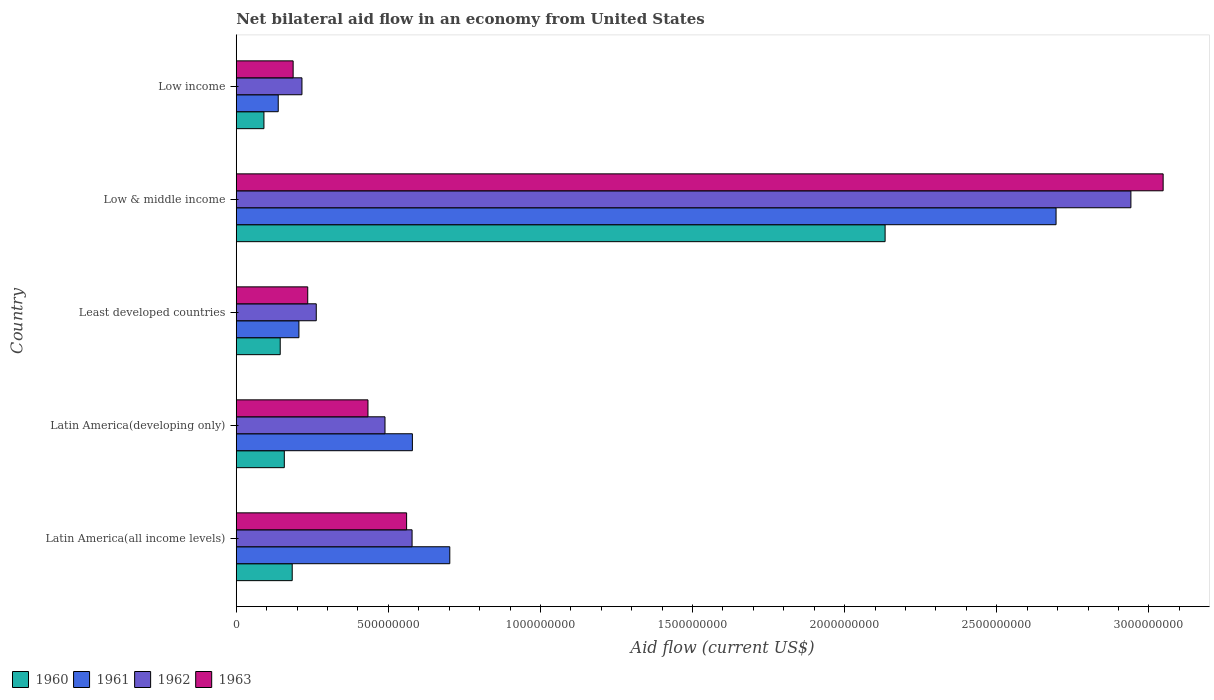Are the number of bars on each tick of the Y-axis equal?
Your answer should be very brief. Yes. How many bars are there on the 3rd tick from the top?
Your answer should be compact. 4. How many bars are there on the 5th tick from the bottom?
Keep it short and to the point. 4. What is the label of the 2nd group of bars from the top?
Your answer should be compact. Low & middle income. What is the net bilateral aid flow in 1960 in Low income?
Ensure brevity in your answer.  9.10e+07. Across all countries, what is the maximum net bilateral aid flow in 1963?
Give a very brief answer. 3.05e+09. Across all countries, what is the minimum net bilateral aid flow in 1962?
Your answer should be very brief. 2.16e+08. In which country was the net bilateral aid flow in 1963 minimum?
Give a very brief answer. Low income. What is the total net bilateral aid flow in 1961 in the graph?
Your response must be concise. 4.32e+09. What is the difference between the net bilateral aid flow in 1960 in Latin America(developing only) and that in Low & middle income?
Provide a short and direct response. -1.98e+09. What is the difference between the net bilateral aid flow in 1963 in Latin America(all income levels) and the net bilateral aid flow in 1961 in Least developed countries?
Offer a terse response. 3.54e+08. What is the average net bilateral aid flow in 1963 per country?
Give a very brief answer. 8.92e+08. What is the difference between the net bilateral aid flow in 1962 and net bilateral aid flow in 1961 in Latin America(all income levels)?
Ensure brevity in your answer.  -1.24e+08. What is the ratio of the net bilateral aid flow in 1961 in Least developed countries to that in Low & middle income?
Your answer should be very brief. 0.08. Is the difference between the net bilateral aid flow in 1962 in Latin America(all income levels) and Latin America(developing only) greater than the difference between the net bilateral aid flow in 1961 in Latin America(all income levels) and Latin America(developing only)?
Your answer should be very brief. No. What is the difference between the highest and the second highest net bilateral aid flow in 1963?
Offer a terse response. 2.49e+09. What is the difference between the highest and the lowest net bilateral aid flow in 1960?
Your answer should be compact. 2.04e+09. In how many countries, is the net bilateral aid flow in 1962 greater than the average net bilateral aid flow in 1962 taken over all countries?
Your answer should be compact. 1. What does the 4th bar from the top in Low income represents?
Provide a short and direct response. 1960. Is it the case that in every country, the sum of the net bilateral aid flow in 1962 and net bilateral aid flow in 1963 is greater than the net bilateral aid flow in 1960?
Provide a succinct answer. Yes. How many bars are there?
Your answer should be compact. 20. Are all the bars in the graph horizontal?
Give a very brief answer. Yes. How many countries are there in the graph?
Keep it short and to the point. 5. What is the difference between two consecutive major ticks on the X-axis?
Provide a succinct answer. 5.00e+08. Does the graph contain any zero values?
Keep it short and to the point. No. Does the graph contain grids?
Your response must be concise. No. What is the title of the graph?
Keep it short and to the point. Net bilateral aid flow in an economy from United States. What is the label or title of the X-axis?
Your answer should be compact. Aid flow (current US$). What is the label or title of the Y-axis?
Give a very brief answer. Country. What is the Aid flow (current US$) of 1960 in Latin America(all income levels)?
Provide a succinct answer. 1.84e+08. What is the Aid flow (current US$) of 1961 in Latin America(all income levels)?
Your answer should be very brief. 7.02e+08. What is the Aid flow (current US$) of 1962 in Latin America(all income levels)?
Provide a succinct answer. 5.78e+08. What is the Aid flow (current US$) of 1963 in Latin America(all income levels)?
Offer a very short reply. 5.60e+08. What is the Aid flow (current US$) in 1960 in Latin America(developing only)?
Make the answer very short. 1.58e+08. What is the Aid flow (current US$) of 1961 in Latin America(developing only)?
Provide a succinct answer. 5.79e+08. What is the Aid flow (current US$) in 1962 in Latin America(developing only)?
Keep it short and to the point. 4.89e+08. What is the Aid flow (current US$) of 1963 in Latin America(developing only)?
Provide a short and direct response. 4.33e+08. What is the Aid flow (current US$) of 1960 in Least developed countries?
Your answer should be compact. 1.45e+08. What is the Aid flow (current US$) in 1961 in Least developed countries?
Offer a very short reply. 2.06e+08. What is the Aid flow (current US$) in 1962 in Least developed countries?
Ensure brevity in your answer.  2.63e+08. What is the Aid flow (current US$) of 1963 in Least developed countries?
Ensure brevity in your answer.  2.35e+08. What is the Aid flow (current US$) of 1960 in Low & middle income?
Your response must be concise. 2.13e+09. What is the Aid flow (current US$) of 1961 in Low & middle income?
Make the answer very short. 2.70e+09. What is the Aid flow (current US$) in 1962 in Low & middle income?
Offer a terse response. 2.94e+09. What is the Aid flow (current US$) of 1963 in Low & middle income?
Offer a very short reply. 3.05e+09. What is the Aid flow (current US$) of 1960 in Low income?
Offer a very short reply. 9.10e+07. What is the Aid flow (current US$) of 1961 in Low income?
Your answer should be very brief. 1.38e+08. What is the Aid flow (current US$) in 1962 in Low income?
Your answer should be compact. 2.16e+08. What is the Aid flow (current US$) of 1963 in Low income?
Give a very brief answer. 1.87e+08. Across all countries, what is the maximum Aid flow (current US$) of 1960?
Keep it short and to the point. 2.13e+09. Across all countries, what is the maximum Aid flow (current US$) of 1961?
Provide a short and direct response. 2.70e+09. Across all countries, what is the maximum Aid flow (current US$) in 1962?
Ensure brevity in your answer.  2.94e+09. Across all countries, what is the maximum Aid flow (current US$) of 1963?
Your answer should be compact. 3.05e+09. Across all countries, what is the minimum Aid flow (current US$) in 1960?
Provide a short and direct response. 9.10e+07. Across all countries, what is the minimum Aid flow (current US$) in 1961?
Keep it short and to the point. 1.38e+08. Across all countries, what is the minimum Aid flow (current US$) in 1962?
Your response must be concise. 2.16e+08. Across all countries, what is the minimum Aid flow (current US$) in 1963?
Your answer should be compact. 1.87e+08. What is the total Aid flow (current US$) of 1960 in the graph?
Make the answer very short. 2.71e+09. What is the total Aid flow (current US$) in 1961 in the graph?
Your answer should be very brief. 4.32e+09. What is the total Aid flow (current US$) in 1962 in the graph?
Offer a very short reply. 4.49e+09. What is the total Aid flow (current US$) of 1963 in the graph?
Offer a very short reply. 4.46e+09. What is the difference between the Aid flow (current US$) in 1960 in Latin America(all income levels) and that in Latin America(developing only)?
Offer a terse response. 2.60e+07. What is the difference between the Aid flow (current US$) in 1961 in Latin America(all income levels) and that in Latin America(developing only)?
Your response must be concise. 1.23e+08. What is the difference between the Aid flow (current US$) in 1962 in Latin America(all income levels) and that in Latin America(developing only)?
Offer a very short reply. 8.90e+07. What is the difference between the Aid flow (current US$) of 1963 in Latin America(all income levels) and that in Latin America(developing only)?
Give a very brief answer. 1.27e+08. What is the difference between the Aid flow (current US$) of 1960 in Latin America(all income levels) and that in Least developed countries?
Your answer should be very brief. 3.95e+07. What is the difference between the Aid flow (current US$) of 1961 in Latin America(all income levels) and that in Least developed countries?
Give a very brief answer. 4.96e+08. What is the difference between the Aid flow (current US$) of 1962 in Latin America(all income levels) and that in Least developed countries?
Your answer should be compact. 3.15e+08. What is the difference between the Aid flow (current US$) of 1963 in Latin America(all income levels) and that in Least developed countries?
Your answer should be very brief. 3.25e+08. What is the difference between the Aid flow (current US$) of 1960 in Latin America(all income levels) and that in Low & middle income?
Provide a short and direct response. -1.95e+09. What is the difference between the Aid flow (current US$) in 1961 in Latin America(all income levels) and that in Low & middle income?
Your answer should be compact. -1.99e+09. What is the difference between the Aid flow (current US$) in 1962 in Latin America(all income levels) and that in Low & middle income?
Provide a succinct answer. -2.36e+09. What is the difference between the Aid flow (current US$) of 1963 in Latin America(all income levels) and that in Low & middle income?
Provide a short and direct response. -2.49e+09. What is the difference between the Aid flow (current US$) of 1960 in Latin America(all income levels) and that in Low income?
Offer a terse response. 9.30e+07. What is the difference between the Aid flow (current US$) in 1961 in Latin America(all income levels) and that in Low income?
Provide a short and direct response. 5.64e+08. What is the difference between the Aid flow (current US$) of 1962 in Latin America(all income levels) and that in Low income?
Your answer should be very brief. 3.62e+08. What is the difference between the Aid flow (current US$) of 1963 in Latin America(all income levels) and that in Low income?
Provide a short and direct response. 3.73e+08. What is the difference between the Aid flow (current US$) in 1960 in Latin America(developing only) and that in Least developed countries?
Keep it short and to the point. 1.35e+07. What is the difference between the Aid flow (current US$) in 1961 in Latin America(developing only) and that in Least developed countries?
Provide a short and direct response. 3.73e+08. What is the difference between the Aid flow (current US$) of 1962 in Latin America(developing only) and that in Least developed countries?
Ensure brevity in your answer.  2.26e+08. What is the difference between the Aid flow (current US$) of 1963 in Latin America(developing only) and that in Least developed countries?
Your response must be concise. 1.98e+08. What is the difference between the Aid flow (current US$) of 1960 in Latin America(developing only) and that in Low & middle income?
Keep it short and to the point. -1.98e+09. What is the difference between the Aid flow (current US$) of 1961 in Latin America(developing only) and that in Low & middle income?
Provide a succinct answer. -2.12e+09. What is the difference between the Aid flow (current US$) in 1962 in Latin America(developing only) and that in Low & middle income?
Keep it short and to the point. -2.45e+09. What is the difference between the Aid flow (current US$) of 1963 in Latin America(developing only) and that in Low & middle income?
Make the answer very short. -2.61e+09. What is the difference between the Aid flow (current US$) of 1960 in Latin America(developing only) and that in Low income?
Make the answer very short. 6.70e+07. What is the difference between the Aid flow (current US$) in 1961 in Latin America(developing only) and that in Low income?
Your answer should be very brief. 4.41e+08. What is the difference between the Aid flow (current US$) of 1962 in Latin America(developing only) and that in Low income?
Offer a terse response. 2.73e+08. What is the difference between the Aid flow (current US$) in 1963 in Latin America(developing only) and that in Low income?
Your answer should be very brief. 2.46e+08. What is the difference between the Aid flow (current US$) in 1960 in Least developed countries and that in Low & middle income?
Offer a terse response. -1.99e+09. What is the difference between the Aid flow (current US$) in 1961 in Least developed countries and that in Low & middle income?
Keep it short and to the point. -2.49e+09. What is the difference between the Aid flow (current US$) in 1962 in Least developed countries and that in Low & middle income?
Provide a short and direct response. -2.68e+09. What is the difference between the Aid flow (current US$) in 1963 in Least developed countries and that in Low & middle income?
Offer a very short reply. -2.81e+09. What is the difference between the Aid flow (current US$) in 1960 in Least developed countries and that in Low income?
Your answer should be very brief. 5.35e+07. What is the difference between the Aid flow (current US$) in 1961 in Least developed countries and that in Low income?
Give a very brief answer. 6.80e+07. What is the difference between the Aid flow (current US$) of 1962 in Least developed countries and that in Low income?
Make the answer very short. 4.70e+07. What is the difference between the Aid flow (current US$) of 1963 in Least developed countries and that in Low income?
Your answer should be very brief. 4.80e+07. What is the difference between the Aid flow (current US$) of 1960 in Low & middle income and that in Low income?
Give a very brief answer. 2.04e+09. What is the difference between the Aid flow (current US$) of 1961 in Low & middle income and that in Low income?
Provide a succinct answer. 2.56e+09. What is the difference between the Aid flow (current US$) in 1962 in Low & middle income and that in Low income?
Your answer should be compact. 2.72e+09. What is the difference between the Aid flow (current US$) of 1963 in Low & middle income and that in Low income?
Provide a succinct answer. 2.86e+09. What is the difference between the Aid flow (current US$) of 1960 in Latin America(all income levels) and the Aid flow (current US$) of 1961 in Latin America(developing only)?
Your response must be concise. -3.95e+08. What is the difference between the Aid flow (current US$) in 1960 in Latin America(all income levels) and the Aid flow (current US$) in 1962 in Latin America(developing only)?
Your answer should be very brief. -3.05e+08. What is the difference between the Aid flow (current US$) in 1960 in Latin America(all income levels) and the Aid flow (current US$) in 1963 in Latin America(developing only)?
Offer a terse response. -2.49e+08. What is the difference between the Aid flow (current US$) of 1961 in Latin America(all income levels) and the Aid flow (current US$) of 1962 in Latin America(developing only)?
Provide a short and direct response. 2.13e+08. What is the difference between the Aid flow (current US$) of 1961 in Latin America(all income levels) and the Aid flow (current US$) of 1963 in Latin America(developing only)?
Your answer should be compact. 2.69e+08. What is the difference between the Aid flow (current US$) of 1962 in Latin America(all income levels) and the Aid flow (current US$) of 1963 in Latin America(developing only)?
Provide a short and direct response. 1.45e+08. What is the difference between the Aid flow (current US$) in 1960 in Latin America(all income levels) and the Aid flow (current US$) in 1961 in Least developed countries?
Your answer should be very brief. -2.20e+07. What is the difference between the Aid flow (current US$) in 1960 in Latin America(all income levels) and the Aid flow (current US$) in 1962 in Least developed countries?
Your response must be concise. -7.90e+07. What is the difference between the Aid flow (current US$) in 1960 in Latin America(all income levels) and the Aid flow (current US$) in 1963 in Least developed countries?
Provide a short and direct response. -5.10e+07. What is the difference between the Aid flow (current US$) of 1961 in Latin America(all income levels) and the Aid flow (current US$) of 1962 in Least developed countries?
Offer a very short reply. 4.39e+08. What is the difference between the Aid flow (current US$) of 1961 in Latin America(all income levels) and the Aid flow (current US$) of 1963 in Least developed countries?
Provide a short and direct response. 4.67e+08. What is the difference between the Aid flow (current US$) in 1962 in Latin America(all income levels) and the Aid flow (current US$) in 1963 in Least developed countries?
Make the answer very short. 3.43e+08. What is the difference between the Aid flow (current US$) in 1960 in Latin America(all income levels) and the Aid flow (current US$) in 1961 in Low & middle income?
Keep it short and to the point. -2.51e+09. What is the difference between the Aid flow (current US$) in 1960 in Latin America(all income levels) and the Aid flow (current US$) in 1962 in Low & middle income?
Provide a succinct answer. -2.76e+09. What is the difference between the Aid flow (current US$) of 1960 in Latin America(all income levels) and the Aid flow (current US$) of 1963 in Low & middle income?
Give a very brief answer. -2.86e+09. What is the difference between the Aid flow (current US$) of 1961 in Latin America(all income levels) and the Aid flow (current US$) of 1962 in Low & middle income?
Your answer should be compact. -2.24e+09. What is the difference between the Aid flow (current US$) in 1961 in Latin America(all income levels) and the Aid flow (current US$) in 1963 in Low & middle income?
Your response must be concise. -2.34e+09. What is the difference between the Aid flow (current US$) in 1962 in Latin America(all income levels) and the Aid flow (current US$) in 1963 in Low & middle income?
Offer a very short reply. -2.47e+09. What is the difference between the Aid flow (current US$) of 1960 in Latin America(all income levels) and the Aid flow (current US$) of 1961 in Low income?
Offer a terse response. 4.60e+07. What is the difference between the Aid flow (current US$) in 1960 in Latin America(all income levels) and the Aid flow (current US$) in 1962 in Low income?
Provide a succinct answer. -3.20e+07. What is the difference between the Aid flow (current US$) in 1960 in Latin America(all income levels) and the Aid flow (current US$) in 1963 in Low income?
Keep it short and to the point. -3.00e+06. What is the difference between the Aid flow (current US$) in 1961 in Latin America(all income levels) and the Aid flow (current US$) in 1962 in Low income?
Provide a short and direct response. 4.86e+08. What is the difference between the Aid flow (current US$) of 1961 in Latin America(all income levels) and the Aid flow (current US$) of 1963 in Low income?
Your answer should be very brief. 5.15e+08. What is the difference between the Aid flow (current US$) of 1962 in Latin America(all income levels) and the Aid flow (current US$) of 1963 in Low income?
Offer a very short reply. 3.91e+08. What is the difference between the Aid flow (current US$) of 1960 in Latin America(developing only) and the Aid flow (current US$) of 1961 in Least developed countries?
Give a very brief answer. -4.80e+07. What is the difference between the Aid flow (current US$) of 1960 in Latin America(developing only) and the Aid flow (current US$) of 1962 in Least developed countries?
Provide a short and direct response. -1.05e+08. What is the difference between the Aid flow (current US$) of 1960 in Latin America(developing only) and the Aid flow (current US$) of 1963 in Least developed countries?
Ensure brevity in your answer.  -7.70e+07. What is the difference between the Aid flow (current US$) in 1961 in Latin America(developing only) and the Aid flow (current US$) in 1962 in Least developed countries?
Make the answer very short. 3.16e+08. What is the difference between the Aid flow (current US$) in 1961 in Latin America(developing only) and the Aid flow (current US$) in 1963 in Least developed countries?
Offer a terse response. 3.44e+08. What is the difference between the Aid flow (current US$) of 1962 in Latin America(developing only) and the Aid flow (current US$) of 1963 in Least developed countries?
Your answer should be very brief. 2.54e+08. What is the difference between the Aid flow (current US$) in 1960 in Latin America(developing only) and the Aid flow (current US$) in 1961 in Low & middle income?
Provide a short and direct response. -2.54e+09. What is the difference between the Aid flow (current US$) of 1960 in Latin America(developing only) and the Aid flow (current US$) of 1962 in Low & middle income?
Give a very brief answer. -2.78e+09. What is the difference between the Aid flow (current US$) in 1960 in Latin America(developing only) and the Aid flow (current US$) in 1963 in Low & middle income?
Provide a succinct answer. -2.89e+09. What is the difference between the Aid flow (current US$) of 1961 in Latin America(developing only) and the Aid flow (current US$) of 1962 in Low & middle income?
Provide a short and direct response. -2.36e+09. What is the difference between the Aid flow (current US$) of 1961 in Latin America(developing only) and the Aid flow (current US$) of 1963 in Low & middle income?
Provide a short and direct response. -2.47e+09. What is the difference between the Aid flow (current US$) in 1962 in Latin America(developing only) and the Aid flow (current US$) in 1963 in Low & middle income?
Offer a terse response. -2.56e+09. What is the difference between the Aid flow (current US$) of 1960 in Latin America(developing only) and the Aid flow (current US$) of 1961 in Low income?
Your answer should be compact. 2.00e+07. What is the difference between the Aid flow (current US$) of 1960 in Latin America(developing only) and the Aid flow (current US$) of 1962 in Low income?
Provide a succinct answer. -5.80e+07. What is the difference between the Aid flow (current US$) of 1960 in Latin America(developing only) and the Aid flow (current US$) of 1963 in Low income?
Make the answer very short. -2.90e+07. What is the difference between the Aid flow (current US$) of 1961 in Latin America(developing only) and the Aid flow (current US$) of 1962 in Low income?
Offer a very short reply. 3.63e+08. What is the difference between the Aid flow (current US$) in 1961 in Latin America(developing only) and the Aid flow (current US$) in 1963 in Low income?
Ensure brevity in your answer.  3.92e+08. What is the difference between the Aid flow (current US$) in 1962 in Latin America(developing only) and the Aid flow (current US$) in 1963 in Low income?
Keep it short and to the point. 3.02e+08. What is the difference between the Aid flow (current US$) of 1960 in Least developed countries and the Aid flow (current US$) of 1961 in Low & middle income?
Offer a very short reply. -2.55e+09. What is the difference between the Aid flow (current US$) in 1960 in Least developed countries and the Aid flow (current US$) in 1962 in Low & middle income?
Ensure brevity in your answer.  -2.80e+09. What is the difference between the Aid flow (current US$) of 1960 in Least developed countries and the Aid flow (current US$) of 1963 in Low & middle income?
Give a very brief answer. -2.90e+09. What is the difference between the Aid flow (current US$) in 1961 in Least developed countries and the Aid flow (current US$) in 1962 in Low & middle income?
Your response must be concise. -2.74e+09. What is the difference between the Aid flow (current US$) in 1961 in Least developed countries and the Aid flow (current US$) in 1963 in Low & middle income?
Ensure brevity in your answer.  -2.84e+09. What is the difference between the Aid flow (current US$) of 1962 in Least developed countries and the Aid flow (current US$) of 1963 in Low & middle income?
Give a very brief answer. -2.78e+09. What is the difference between the Aid flow (current US$) of 1960 in Least developed countries and the Aid flow (current US$) of 1961 in Low income?
Ensure brevity in your answer.  6.52e+06. What is the difference between the Aid flow (current US$) in 1960 in Least developed countries and the Aid flow (current US$) in 1962 in Low income?
Your response must be concise. -7.15e+07. What is the difference between the Aid flow (current US$) in 1960 in Least developed countries and the Aid flow (current US$) in 1963 in Low income?
Your answer should be compact. -4.25e+07. What is the difference between the Aid flow (current US$) in 1961 in Least developed countries and the Aid flow (current US$) in 1962 in Low income?
Provide a succinct answer. -1.00e+07. What is the difference between the Aid flow (current US$) in 1961 in Least developed countries and the Aid flow (current US$) in 1963 in Low income?
Offer a very short reply. 1.90e+07. What is the difference between the Aid flow (current US$) in 1962 in Least developed countries and the Aid flow (current US$) in 1963 in Low income?
Your answer should be compact. 7.60e+07. What is the difference between the Aid flow (current US$) in 1960 in Low & middle income and the Aid flow (current US$) in 1961 in Low income?
Your answer should be compact. 2.00e+09. What is the difference between the Aid flow (current US$) in 1960 in Low & middle income and the Aid flow (current US$) in 1962 in Low income?
Offer a very short reply. 1.92e+09. What is the difference between the Aid flow (current US$) in 1960 in Low & middle income and the Aid flow (current US$) in 1963 in Low income?
Your answer should be very brief. 1.95e+09. What is the difference between the Aid flow (current US$) of 1961 in Low & middle income and the Aid flow (current US$) of 1962 in Low income?
Your answer should be compact. 2.48e+09. What is the difference between the Aid flow (current US$) of 1961 in Low & middle income and the Aid flow (current US$) of 1963 in Low income?
Offer a very short reply. 2.51e+09. What is the difference between the Aid flow (current US$) of 1962 in Low & middle income and the Aid flow (current US$) of 1963 in Low income?
Your response must be concise. 2.75e+09. What is the average Aid flow (current US$) in 1960 per country?
Offer a terse response. 5.42e+08. What is the average Aid flow (current US$) in 1961 per country?
Provide a short and direct response. 8.64e+08. What is the average Aid flow (current US$) of 1962 per country?
Your response must be concise. 8.97e+08. What is the average Aid flow (current US$) of 1963 per country?
Give a very brief answer. 8.92e+08. What is the difference between the Aid flow (current US$) of 1960 and Aid flow (current US$) of 1961 in Latin America(all income levels)?
Keep it short and to the point. -5.18e+08. What is the difference between the Aid flow (current US$) of 1960 and Aid flow (current US$) of 1962 in Latin America(all income levels)?
Ensure brevity in your answer.  -3.94e+08. What is the difference between the Aid flow (current US$) of 1960 and Aid flow (current US$) of 1963 in Latin America(all income levels)?
Make the answer very short. -3.76e+08. What is the difference between the Aid flow (current US$) of 1961 and Aid flow (current US$) of 1962 in Latin America(all income levels)?
Your answer should be very brief. 1.24e+08. What is the difference between the Aid flow (current US$) of 1961 and Aid flow (current US$) of 1963 in Latin America(all income levels)?
Provide a succinct answer. 1.42e+08. What is the difference between the Aid flow (current US$) in 1962 and Aid flow (current US$) in 1963 in Latin America(all income levels)?
Provide a short and direct response. 1.80e+07. What is the difference between the Aid flow (current US$) in 1960 and Aid flow (current US$) in 1961 in Latin America(developing only)?
Your answer should be compact. -4.21e+08. What is the difference between the Aid flow (current US$) of 1960 and Aid flow (current US$) of 1962 in Latin America(developing only)?
Provide a succinct answer. -3.31e+08. What is the difference between the Aid flow (current US$) of 1960 and Aid flow (current US$) of 1963 in Latin America(developing only)?
Make the answer very short. -2.75e+08. What is the difference between the Aid flow (current US$) of 1961 and Aid flow (current US$) of 1962 in Latin America(developing only)?
Your response must be concise. 9.00e+07. What is the difference between the Aid flow (current US$) in 1961 and Aid flow (current US$) in 1963 in Latin America(developing only)?
Offer a terse response. 1.46e+08. What is the difference between the Aid flow (current US$) of 1962 and Aid flow (current US$) of 1963 in Latin America(developing only)?
Your answer should be very brief. 5.60e+07. What is the difference between the Aid flow (current US$) of 1960 and Aid flow (current US$) of 1961 in Least developed countries?
Give a very brief answer. -6.15e+07. What is the difference between the Aid flow (current US$) in 1960 and Aid flow (current US$) in 1962 in Least developed countries?
Offer a terse response. -1.18e+08. What is the difference between the Aid flow (current US$) in 1960 and Aid flow (current US$) in 1963 in Least developed countries?
Offer a terse response. -9.05e+07. What is the difference between the Aid flow (current US$) of 1961 and Aid flow (current US$) of 1962 in Least developed countries?
Provide a short and direct response. -5.70e+07. What is the difference between the Aid flow (current US$) of 1961 and Aid flow (current US$) of 1963 in Least developed countries?
Provide a short and direct response. -2.90e+07. What is the difference between the Aid flow (current US$) in 1962 and Aid flow (current US$) in 1963 in Least developed countries?
Give a very brief answer. 2.80e+07. What is the difference between the Aid flow (current US$) in 1960 and Aid flow (current US$) in 1961 in Low & middle income?
Your answer should be very brief. -5.62e+08. What is the difference between the Aid flow (current US$) of 1960 and Aid flow (current US$) of 1962 in Low & middle income?
Offer a terse response. -8.08e+08. What is the difference between the Aid flow (current US$) of 1960 and Aid flow (current US$) of 1963 in Low & middle income?
Provide a succinct answer. -9.14e+08. What is the difference between the Aid flow (current US$) in 1961 and Aid flow (current US$) in 1962 in Low & middle income?
Provide a short and direct response. -2.46e+08. What is the difference between the Aid flow (current US$) of 1961 and Aid flow (current US$) of 1963 in Low & middle income?
Your response must be concise. -3.52e+08. What is the difference between the Aid flow (current US$) in 1962 and Aid flow (current US$) in 1963 in Low & middle income?
Keep it short and to the point. -1.06e+08. What is the difference between the Aid flow (current US$) in 1960 and Aid flow (current US$) in 1961 in Low income?
Your answer should be compact. -4.70e+07. What is the difference between the Aid flow (current US$) of 1960 and Aid flow (current US$) of 1962 in Low income?
Your answer should be very brief. -1.25e+08. What is the difference between the Aid flow (current US$) in 1960 and Aid flow (current US$) in 1963 in Low income?
Your answer should be very brief. -9.60e+07. What is the difference between the Aid flow (current US$) in 1961 and Aid flow (current US$) in 1962 in Low income?
Your answer should be compact. -7.80e+07. What is the difference between the Aid flow (current US$) of 1961 and Aid flow (current US$) of 1963 in Low income?
Provide a short and direct response. -4.90e+07. What is the difference between the Aid flow (current US$) of 1962 and Aid flow (current US$) of 1963 in Low income?
Your answer should be compact. 2.90e+07. What is the ratio of the Aid flow (current US$) of 1960 in Latin America(all income levels) to that in Latin America(developing only)?
Ensure brevity in your answer.  1.16. What is the ratio of the Aid flow (current US$) in 1961 in Latin America(all income levels) to that in Latin America(developing only)?
Give a very brief answer. 1.21. What is the ratio of the Aid flow (current US$) in 1962 in Latin America(all income levels) to that in Latin America(developing only)?
Give a very brief answer. 1.18. What is the ratio of the Aid flow (current US$) in 1963 in Latin America(all income levels) to that in Latin America(developing only)?
Give a very brief answer. 1.29. What is the ratio of the Aid flow (current US$) of 1960 in Latin America(all income levels) to that in Least developed countries?
Provide a succinct answer. 1.27. What is the ratio of the Aid flow (current US$) in 1961 in Latin America(all income levels) to that in Least developed countries?
Provide a succinct answer. 3.41. What is the ratio of the Aid flow (current US$) in 1962 in Latin America(all income levels) to that in Least developed countries?
Your answer should be very brief. 2.2. What is the ratio of the Aid flow (current US$) in 1963 in Latin America(all income levels) to that in Least developed countries?
Offer a terse response. 2.38. What is the ratio of the Aid flow (current US$) in 1960 in Latin America(all income levels) to that in Low & middle income?
Ensure brevity in your answer.  0.09. What is the ratio of the Aid flow (current US$) in 1961 in Latin America(all income levels) to that in Low & middle income?
Offer a terse response. 0.26. What is the ratio of the Aid flow (current US$) of 1962 in Latin America(all income levels) to that in Low & middle income?
Keep it short and to the point. 0.2. What is the ratio of the Aid flow (current US$) of 1963 in Latin America(all income levels) to that in Low & middle income?
Give a very brief answer. 0.18. What is the ratio of the Aid flow (current US$) in 1960 in Latin America(all income levels) to that in Low income?
Your answer should be very brief. 2.02. What is the ratio of the Aid flow (current US$) of 1961 in Latin America(all income levels) to that in Low income?
Ensure brevity in your answer.  5.09. What is the ratio of the Aid flow (current US$) of 1962 in Latin America(all income levels) to that in Low income?
Keep it short and to the point. 2.68. What is the ratio of the Aid flow (current US$) in 1963 in Latin America(all income levels) to that in Low income?
Make the answer very short. 2.99. What is the ratio of the Aid flow (current US$) of 1960 in Latin America(developing only) to that in Least developed countries?
Offer a terse response. 1.09. What is the ratio of the Aid flow (current US$) in 1961 in Latin America(developing only) to that in Least developed countries?
Give a very brief answer. 2.81. What is the ratio of the Aid flow (current US$) of 1962 in Latin America(developing only) to that in Least developed countries?
Your answer should be very brief. 1.86. What is the ratio of the Aid flow (current US$) in 1963 in Latin America(developing only) to that in Least developed countries?
Your answer should be compact. 1.84. What is the ratio of the Aid flow (current US$) of 1960 in Latin America(developing only) to that in Low & middle income?
Offer a very short reply. 0.07. What is the ratio of the Aid flow (current US$) of 1961 in Latin America(developing only) to that in Low & middle income?
Offer a very short reply. 0.21. What is the ratio of the Aid flow (current US$) in 1962 in Latin America(developing only) to that in Low & middle income?
Your answer should be compact. 0.17. What is the ratio of the Aid flow (current US$) of 1963 in Latin America(developing only) to that in Low & middle income?
Make the answer very short. 0.14. What is the ratio of the Aid flow (current US$) in 1960 in Latin America(developing only) to that in Low income?
Give a very brief answer. 1.74. What is the ratio of the Aid flow (current US$) of 1961 in Latin America(developing only) to that in Low income?
Offer a terse response. 4.2. What is the ratio of the Aid flow (current US$) in 1962 in Latin America(developing only) to that in Low income?
Offer a terse response. 2.26. What is the ratio of the Aid flow (current US$) of 1963 in Latin America(developing only) to that in Low income?
Keep it short and to the point. 2.32. What is the ratio of the Aid flow (current US$) of 1960 in Least developed countries to that in Low & middle income?
Provide a short and direct response. 0.07. What is the ratio of the Aid flow (current US$) in 1961 in Least developed countries to that in Low & middle income?
Provide a succinct answer. 0.08. What is the ratio of the Aid flow (current US$) of 1962 in Least developed countries to that in Low & middle income?
Ensure brevity in your answer.  0.09. What is the ratio of the Aid flow (current US$) in 1963 in Least developed countries to that in Low & middle income?
Ensure brevity in your answer.  0.08. What is the ratio of the Aid flow (current US$) of 1960 in Least developed countries to that in Low income?
Your answer should be compact. 1.59. What is the ratio of the Aid flow (current US$) of 1961 in Least developed countries to that in Low income?
Make the answer very short. 1.49. What is the ratio of the Aid flow (current US$) of 1962 in Least developed countries to that in Low income?
Give a very brief answer. 1.22. What is the ratio of the Aid flow (current US$) in 1963 in Least developed countries to that in Low income?
Offer a very short reply. 1.26. What is the ratio of the Aid flow (current US$) in 1960 in Low & middle income to that in Low income?
Provide a short and direct response. 23.44. What is the ratio of the Aid flow (current US$) in 1961 in Low & middle income to that in Low income?
Your answer should be compact. 19.53. What is the ratio of the Aid flow (current US$) of 1962 in Low & middle income to that in Low income?
Provide a short and direct response. 13.62. What is the ratio of the Aid flow (current US$) of 1963 in Low & middle income to that in Low income?
Ensure brevity in your answer.  16.29. What is the difference between the highest and the second highest Aid flow (current US$) in 1960?
Your answer should be compact. 1.95e+09. What is the difference between the highest and the second highest Aid flow (current US$) in 1961?
Your answer should be compact. 1.99e+09. What is the difference between the highest and the second highest Aid flow (current US$) in 1962?
Provide a succinct answer. 2.36e+09. What is the difference between the highest and the second highest Aid flow (current US$) in 1963?
Offer a terse response. 2.49e+09. What is the difference between the highest and the lowest Aid flow (current US$) of 1960?
Your answer should be compact. 2.04e+09. What is the difference between the highest and the lowest Aid flow (current US$) in 1961?
Make the answer very short. 2.56e+09. What is the difference between the highest and the lowest Aid flow (current US$) in 1962?
Offer a very short reply. 2.72e+09. What is the difference between the highest and the lowest Aid flow (current US$) in 1963?
Give a very brief answer. 2.86e+09. 